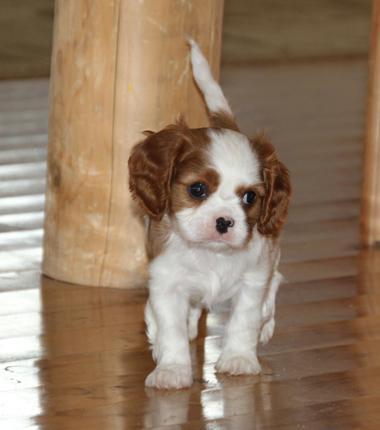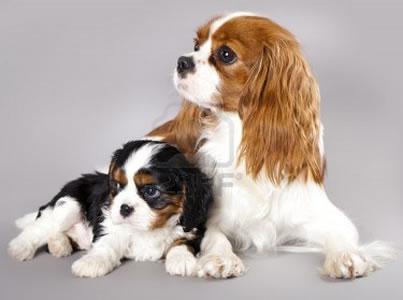The first image is the image on the left, the second image is the image on the right. For the images shown, is this caption "An image shows a yellow toy next to at least one dog." true? Answer yes or no. No. The first image is the image on the left, the second image is the image on the right. Assess this claim about the two images: "There are more dogs in the image on the right than the image on the left.". Correct or not? Answer yes or no. Yes. 